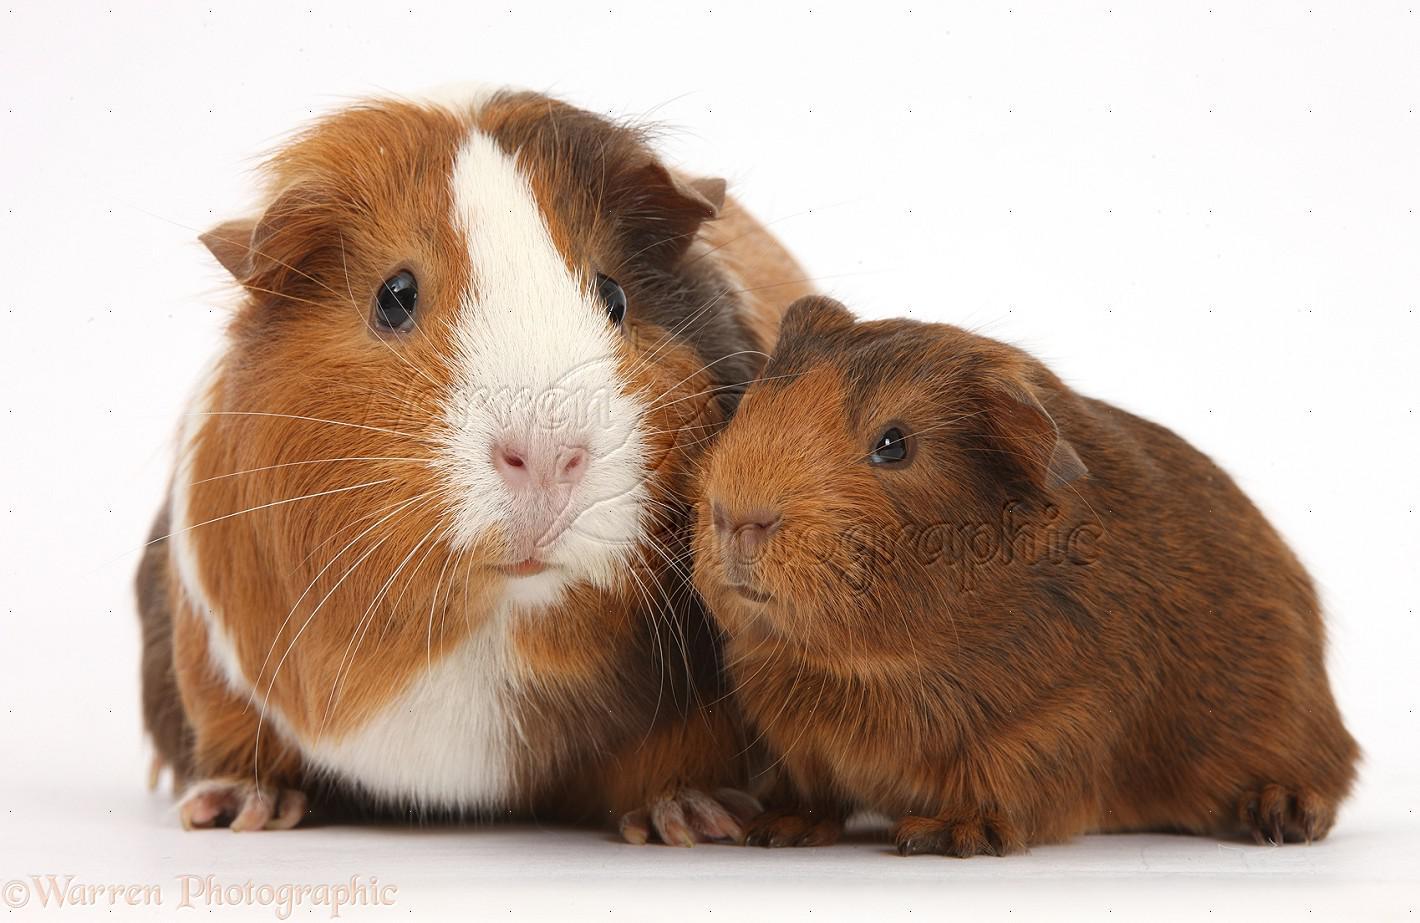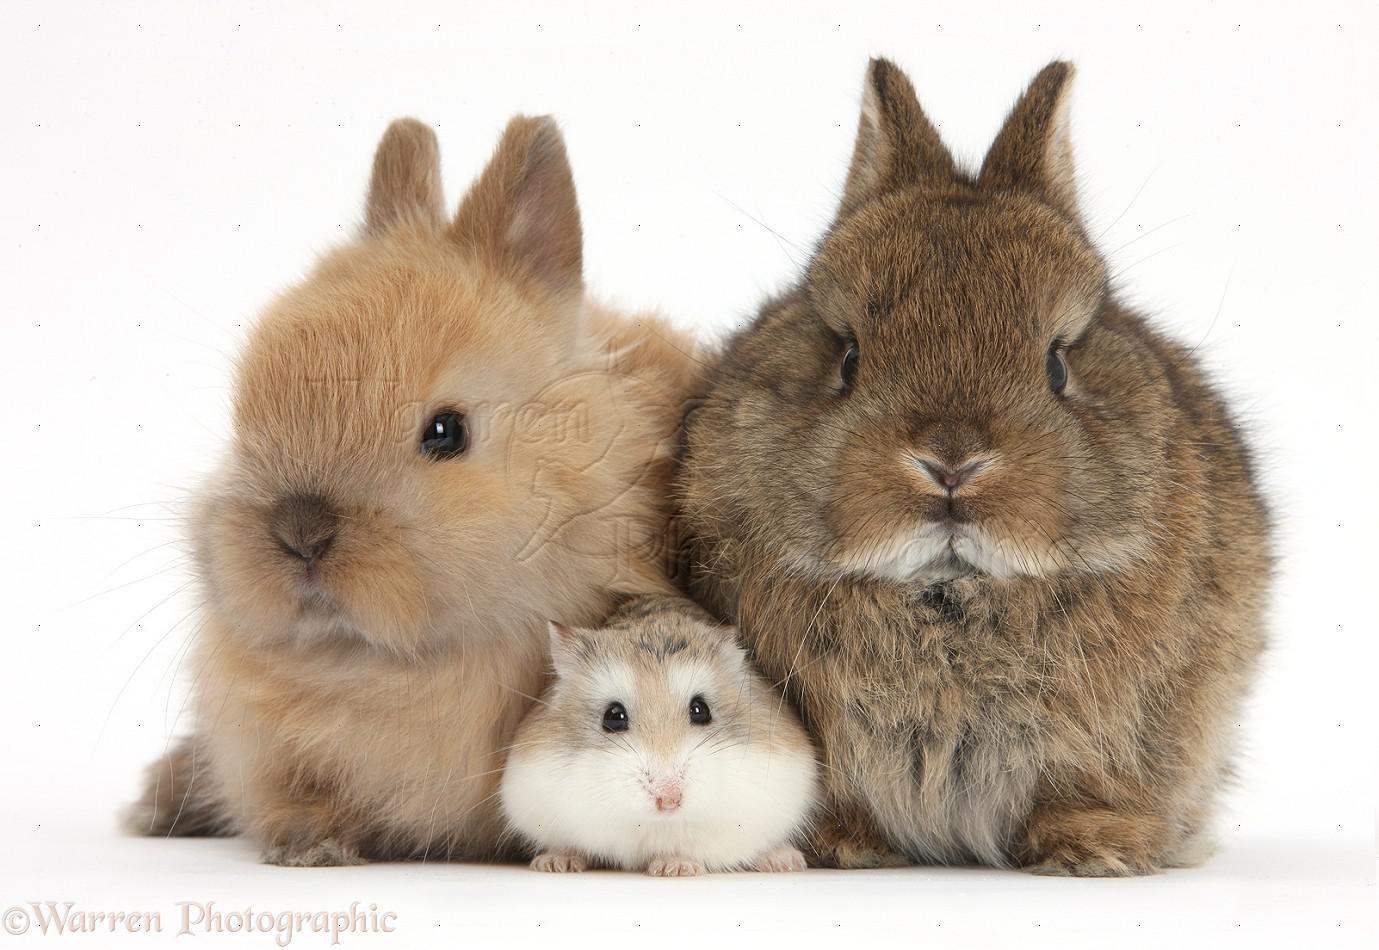The first image is the image on the left, the second image is the image on the right. For the images displayed, is the sentence "One of the images features a small animal in between two rabbits, while the other image features at least two guinea pigs." factually correct? Answer yes or no. Yes. The first image is the image on the left, the second image is the image on the right. Evaluate the accuracy of this statement regarding the images: "The right image contains two rabbits.". Is it true? Answer yes or no. Yes. 